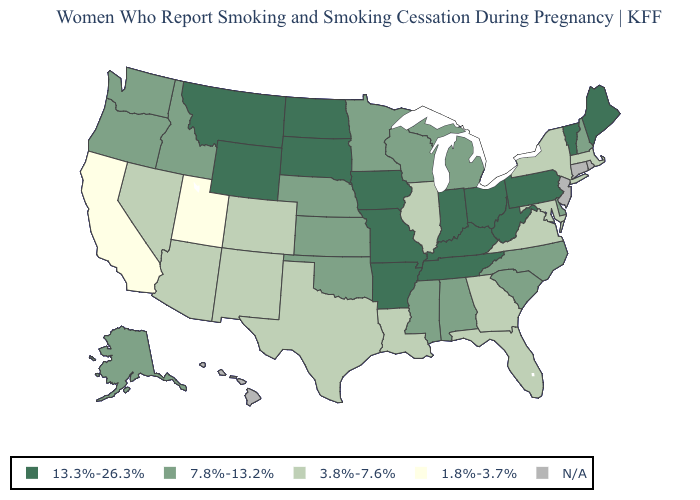What is the value of Texas?
Answer briefly. 3.8%-7.6%. Which states have the lowest value in the USA?
Keep it brief. California, Utah. Does California have the lowest value in the USA?
Quick response, please. Yes. What is the highest value in the USA?
Be succinct. 13.3%-26.3%. What is the value of Nevada?
Concise answer only. 3.8%-7.6%. Name the states that have a value in the range 1.8%-3.7%?
Short answer required. California, Utah. What is the value of South Carolina?
Short answer required. 7.8%-13.2%. Does Utah have the lowest value in the West?
Concise answer only. Yes. What is the value of New Hampshire?
Answer briefly. 7.8%-13.2%. Is the legend a continuous bar?
Concise answer only. No. Is the legend a continuous bar?
Short answer required. No. Is the legend a continuous bar?
Keep it brief. No. What is the lowest value in states that border New Mexico?
Concise answer only. 1.8%-3.7%. 